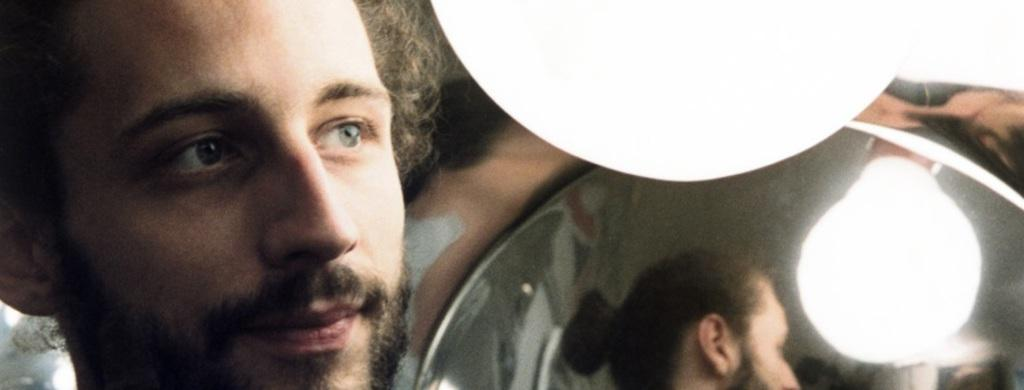Who is present in the image? There is a man in the image. What object can be seen reflecting the man? There is a mirror in the image. Where is the light source located in the image? The light is located on the right side in the image. What type of juice is being served in the image? There is no juice present in the image. 